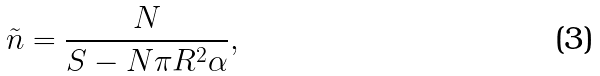<formula> <loc_0><loc_0><loc_500><loc_500>\tilde { n } = \frac { N } { S - N \pi R ^ { 2 } \alpha } ,</formula> 